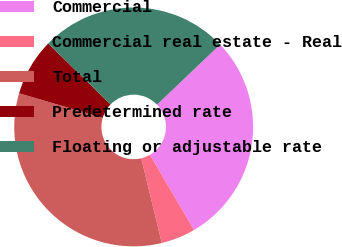Convert chart. <chart><loc_0><loc_0><loc_500><loc_500><pie_chart><fcel>Commercial<fcel>Commercial real estate - Real<fcel>Total<fcel>Predetermined rate<fcel>Floating or adjustable rate<nl><fcel>28.69%<fcel>4.65%<fcel>33.33%<fcel>7.76%<fcel>25.58%<nl></chart> 